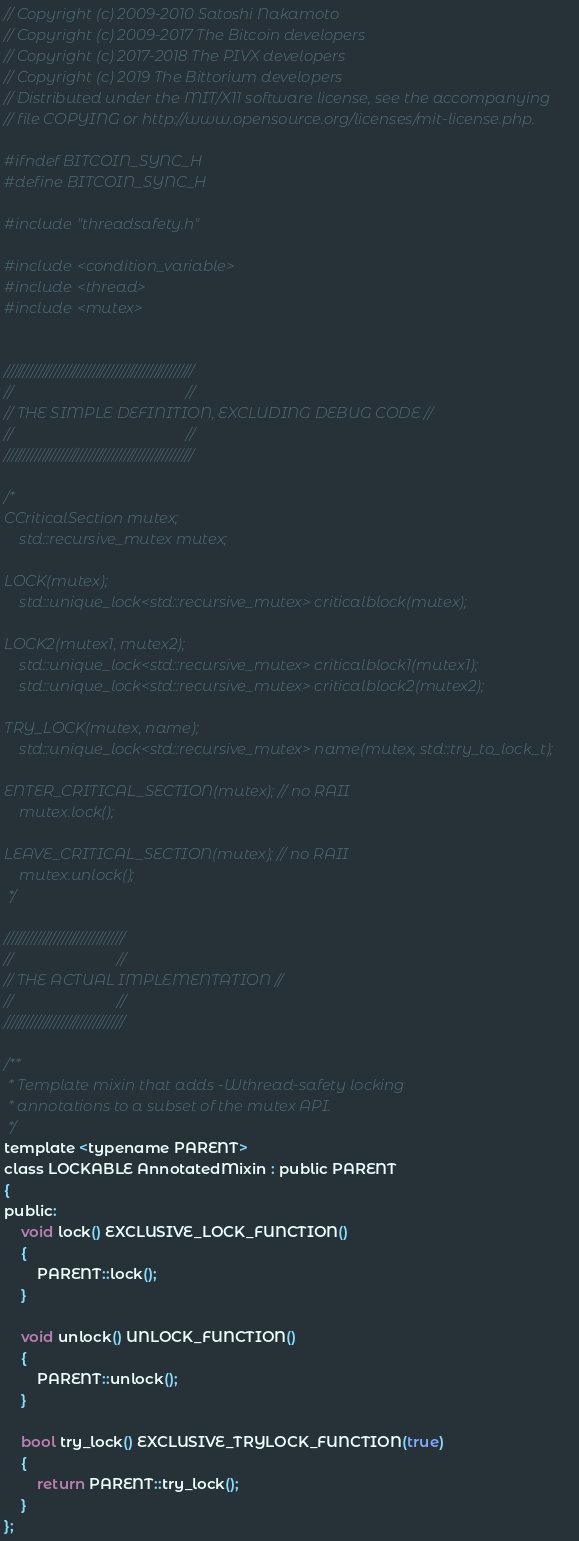Convert code to text. <code><loc_0><loc_0><loc_500><loc_500><_C_>// Copyright (c) 2009-2010 Satoshi Nakamoto
// Copyright (c) 2009-2017 The Bitcoin developers
// Copyright (c) 2017-2018 The PIVX developers
// Copyright (c) 2019 The Bittorium developers
// Distributed under the MIT/X11 software license, see the accompanying
// file COPYING or http://www.opensource.org/licenses/mit-license.php.

#ifndef BITCOIN_SYNC_H
#define BITCOIN_SYNC_H

#include "threadsafety.h"

#include <condition_variable>
#include <thread>
#include <mutex>


/////////////////////////////////////////////////
//                                             //
// THE SIMPLE DEFINITION, EXCLUDING DEBUG CODE //
//                                             //
/////////////////////////////////////////////////

/*
CCriticalSection mutex;
    std::recursive_mutex mutex;

LOCK(mutex);
    std::unique_lock<std::recursive_mutex> criticalblock(mutex);

LOCK2(mutex1, mutex2);
    std::unique_lock<std::recursive_mutex> criticalblock1(mutex1);
    std::unique_lock<std::recursive_mutex> criticalblock2(mutex2);

TRY_LOCK(mutex, name);
    std::unique_lock<std::recursive_mutex> name(mutex, std::try_to_lock_t);

ENTER_CRITICAL_SECTION(mutex); // no RAII
    mutex.lock();

LEAVE_CRITICAL_SECTION(mutex); // no RAII
    mutex.unlock();
 */

///////////////////////////////
//                           //
// THE ACTUAL IMPLEMENTATION //
//                           //
///////////////////////////////

/**
 * Template mixin that adds -Wthread-safety locking
 * annotations to a subset of the mutex API.
 */
template <typename PARENT>
class LOCKABLE AnnotatedMixin : public PARENT
{
public:
    void lock() EXCLUSIVE_LOCK_FUNCTION()
    {
        PARENT::lock();
    }

    void unlock() UNLOCK_FUNCTION()
    {
        PARENT::unlock();
    }

    bool try_lock() EXCLUSIVE_TRYLOCK_FUNCTION(true)
    {
        return PARENT::try_lock();
    }
};
</code> 